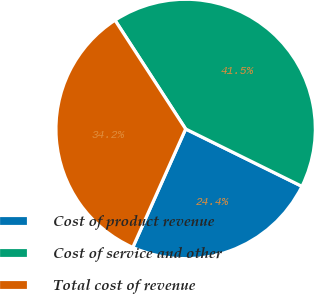<chart> <loc_0><loc_0><loc_500><loc_500><pie_chart><fcel>Cost of product revenue<fcel>Cost of service and other<fcel>Total cost of revenue<nl><fcel>24.39%<fcel>41.46%<fcel>34.15%<nl></chart> 